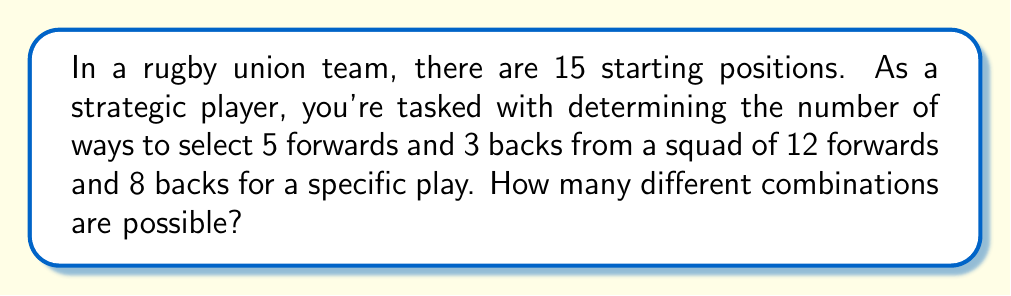Can you solve this math problem? Let's approach this step-by-step:

1) We need to select 5 forwards out of 12 and 3 backs out of 8.

2) For the forwards:
   We can use the combination formula: $${12 \choose 5}$$
   This represents the number of ways to choose 5 forwards from 12.

3) For the backs:
   Similarly, we use: $${8 \choose 3}$$
   This represents the number of ways to choose 3 backs from 8.

4) According to the multiplication principle, the total number of ways to select both forwards and backs is the product of these two combinations:

   $${12 \choose 5} \times {8 \choose 3}$$

5) Let's calculate each part:
   $${12 \choose 5} = \frac{12!}{5!(12-5)!} = \frac{12!}{5!7!} = 792$$
   
   $${8 \choose 3} = \frac{8!}{3!(8-3)!} = \frac{8!}{3!5!} = 56$$

6) Now, we multiply these results:

   $$792 \times 56 = 44,352$$

Therefore, there are 44,352 different possible combinations.
Answer: 44,352 